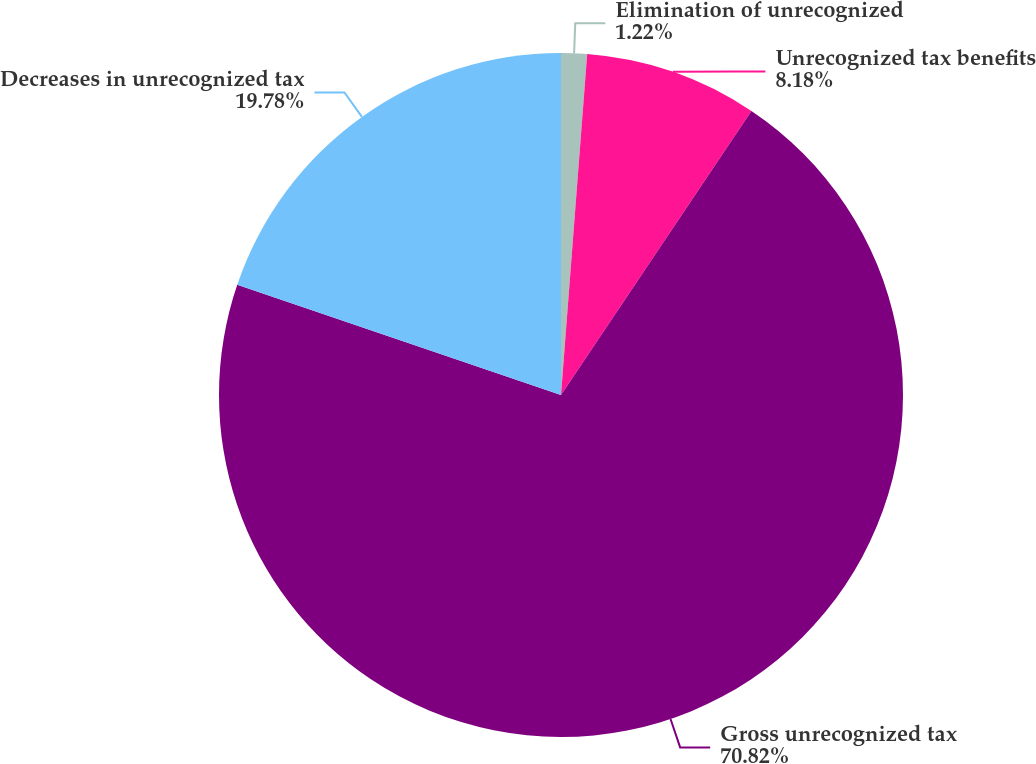Convert chart. <chart><loc_0><loc_0><loc_500><loc_500><pie_chart><fcel>Elimination of unrecognized<fcel>Unrecognized tax benefits<fcel>Gross unrecognized tax<fcel>Decreases in unrecognized tax<nl><fcel>1.22%<fcel>8.18%<fcel>70.83%<fcel>19.78%<nl></chart> 